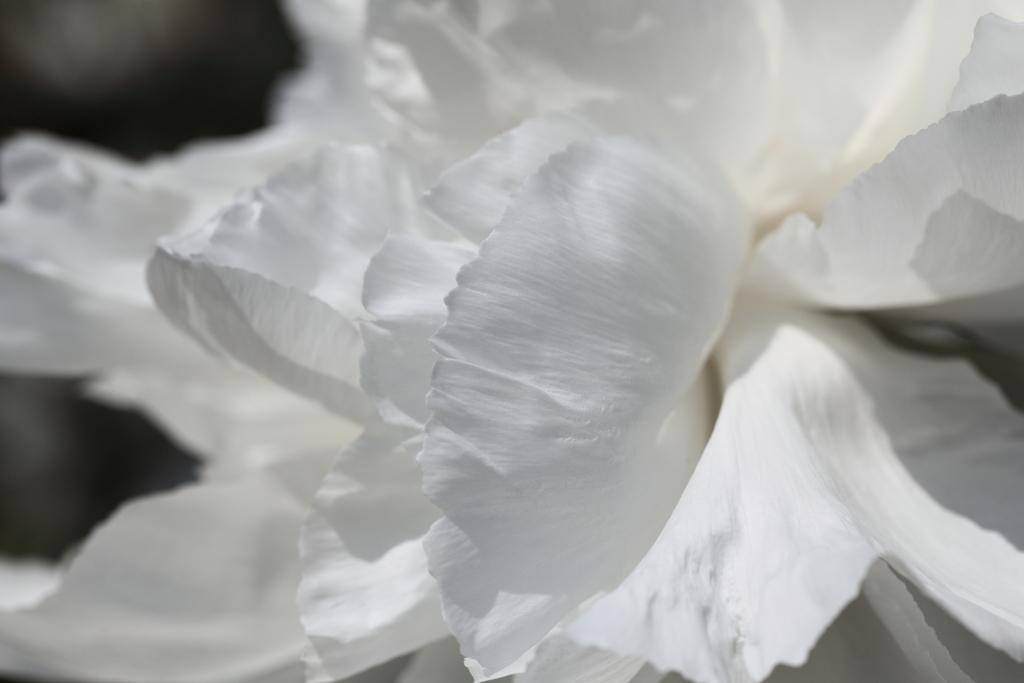What type of flower is in the image? There is a white color flower in the image. How is the flower depicted in the image? The flower is truncated. What time does the watch in the image show? There is no watch present in the image. What is the caption of the image? The image does not have a caption. What scientific theory is being demonstrated in the image? There is no scientific theory being demonstrated in the image. 